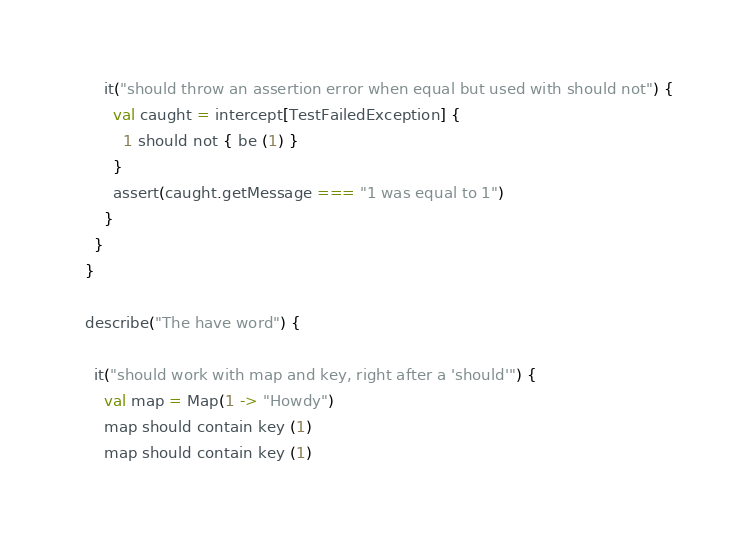Convert code to text. <code><loc_0><loc_0><loc_500><loc_500><_Scala_>
      it("should throw an assertion error when equal but used with should not") {
        val caught = intercept[TestFailedException] {
          1 should not { be (1) }
        }
        assert(caught.getMessage === "1 was equal to 1")
      }
    }
  }

  describe("The have word") {

    it("should work with map and key, right after a 'should'") {
      val map = Map(1 -> "Howdy")
      map should contain key (1)
      map should contain key (1)</code> 